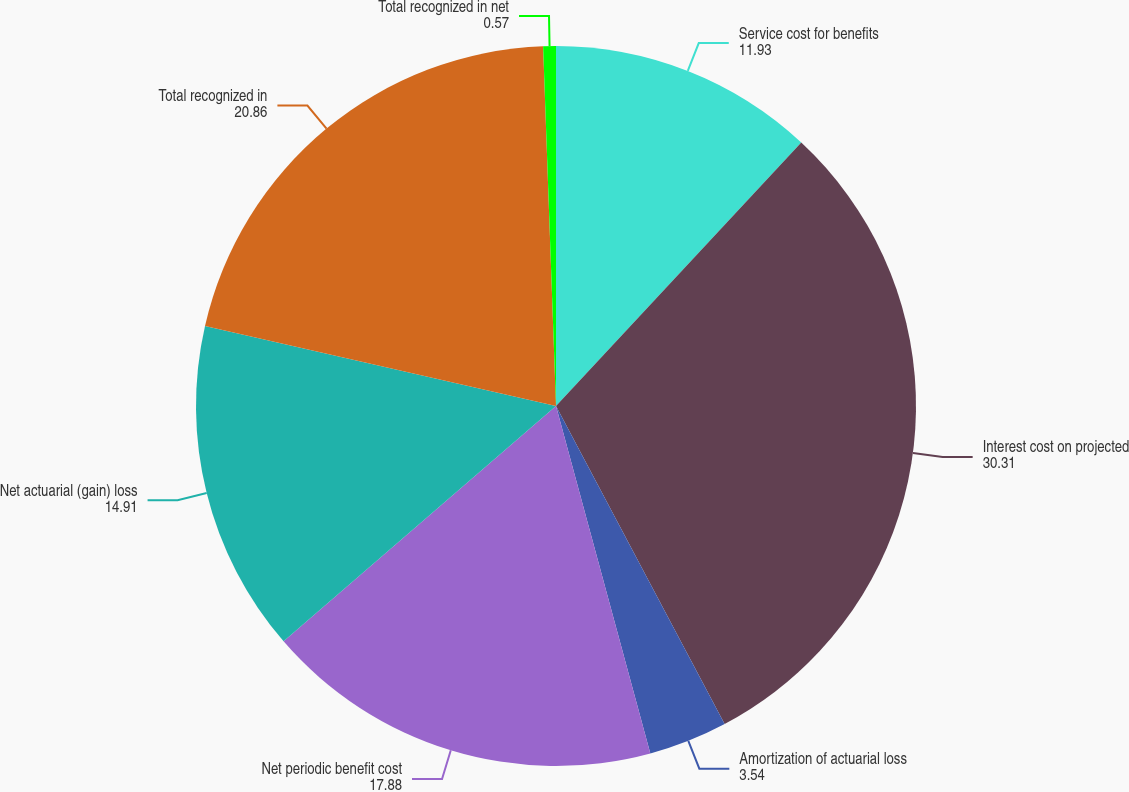Convert chart. <chart><loc_0><loc_0><loc_500><loc_500><pie_chart><fcel>Service cost for benefits<fcel>Interest cost on projected<fcel>Amortization of actuarial loss<fcel>Net periodic benefit cost<fcel>Net actuarial (gain) loss<fcel>Total recognized in<fcel>Total recognized in net<nl><fcel>11.93%<fcel>30.31%<fcel>3.54%<fcel>17.88%<fcel>14.91%<fcel>20.86%<fcel>0.57%<nl></chart> 